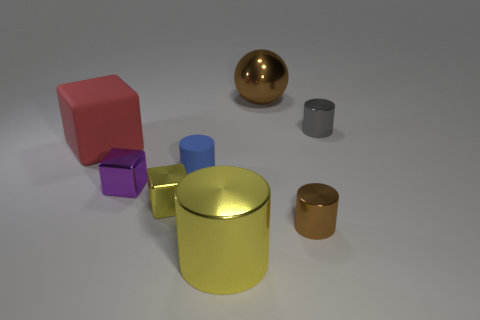Subtract all green cylinders. Subtract all green blocks. How many cylinders are left? 4 Add 1 purple metallic blocks. How many objects exist? 9 Subtract all blocks. How many objects are left? 5 Subtract all small purple matte spheres. Subtract all large metallic cylinders. How many objects are left? 7 Add 4 gray cylinders. How many gray cylinders are left? 5 Add 8 rubber cubes. How many rubber cubes exist? 9 Subtract 1 red blocks. How many objects are left? 7 